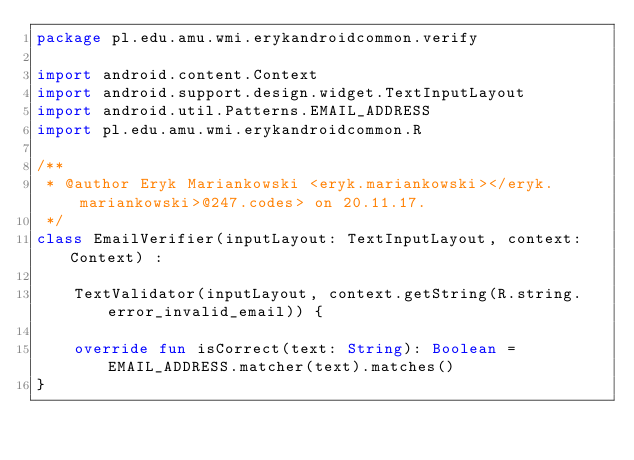<code> <loc_0><loc_0><loc_500><loc_500><_Kotlin_>package pl.edu.amu.wmi.erykandroidcommon.verify

import android.content.Context
import android.support.design.widget.TextInputLayout
import android.util.Patterns.EMAIL_ADDRESS
import pl.edu.amu.wmi.erykandroidcommon.R

/**
 * @author Eryk Mariankowski <eryk.mariankowski></eryk.mariankowski>@247.codes> on 20.11.17.
 */
class EmailVerifier(inputLayout: TextInputLayout, context: Context) :

    TextValidator(inputLayout, context.getString(R.string.error_invalid_email)) {

    override fun isCorrect(text: String): Boolean = EMAIL_ADDRESS.matcher(text).matches()
}</code> 